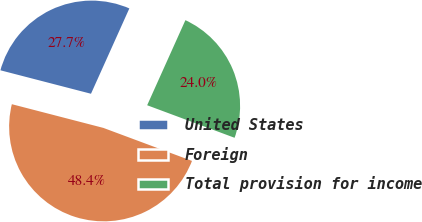Convert chart to OTSL. <chart><loc_0><loc_0><loc_500><loc_500><pie_chart><fcel>United States<fcel>Foreign<fcel>Total provision for income<nl><fcel>27.69%<fcel>48.36%<fcel>23.95%<nl></chart> 